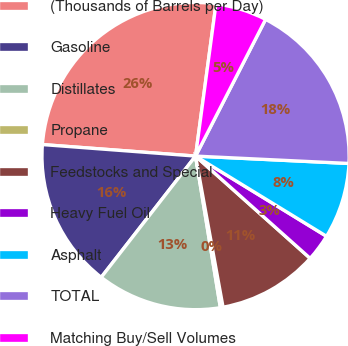<chart> <loc_0><loc_0><loc_500><loc_500><pie_chart><fcel>(Thousands of Barrels per Day)<fcel>Gasoline<fcel>Distillates<fcel>Propane<fcel>Feedstocks and Special<fcel>Heavy Fuel Oil<fcel>Asphalt<fcel>TOTAL<fcel>Matching Buy/Sell Volumes<nl><fcel>25.93%<fcel>15.67%<fcel>13.11%<fcel>0.28%<fcel>10.54%<fcel>2.85%<fcel>7.98%<fcel>18.23%<fcel>5.41%<nl></chart> 